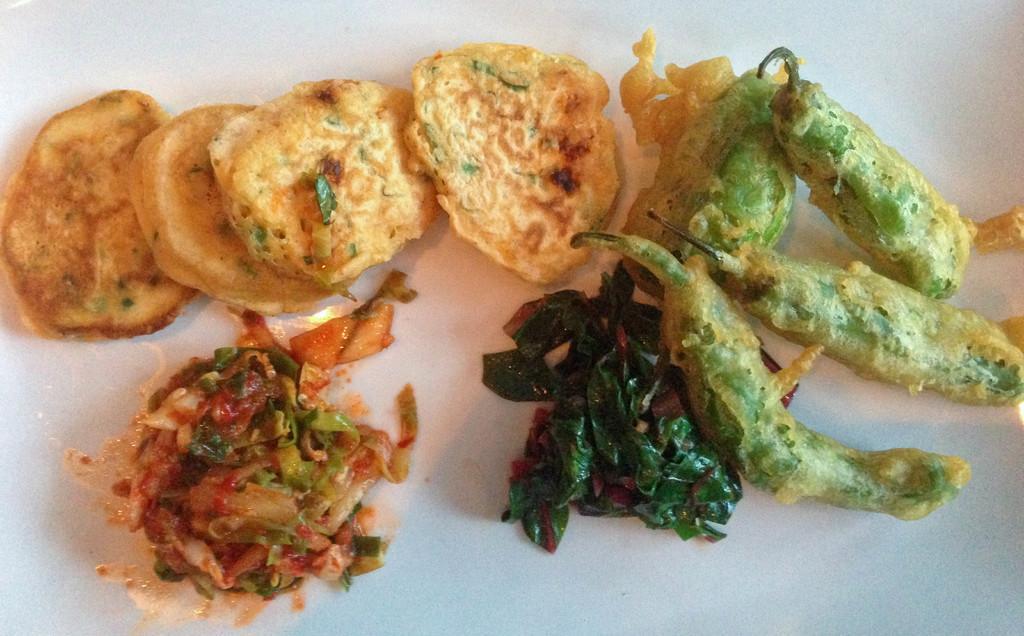How would you summarize this image in a sentence or two? In this image in the center there are some food items, it looks like a plate. 